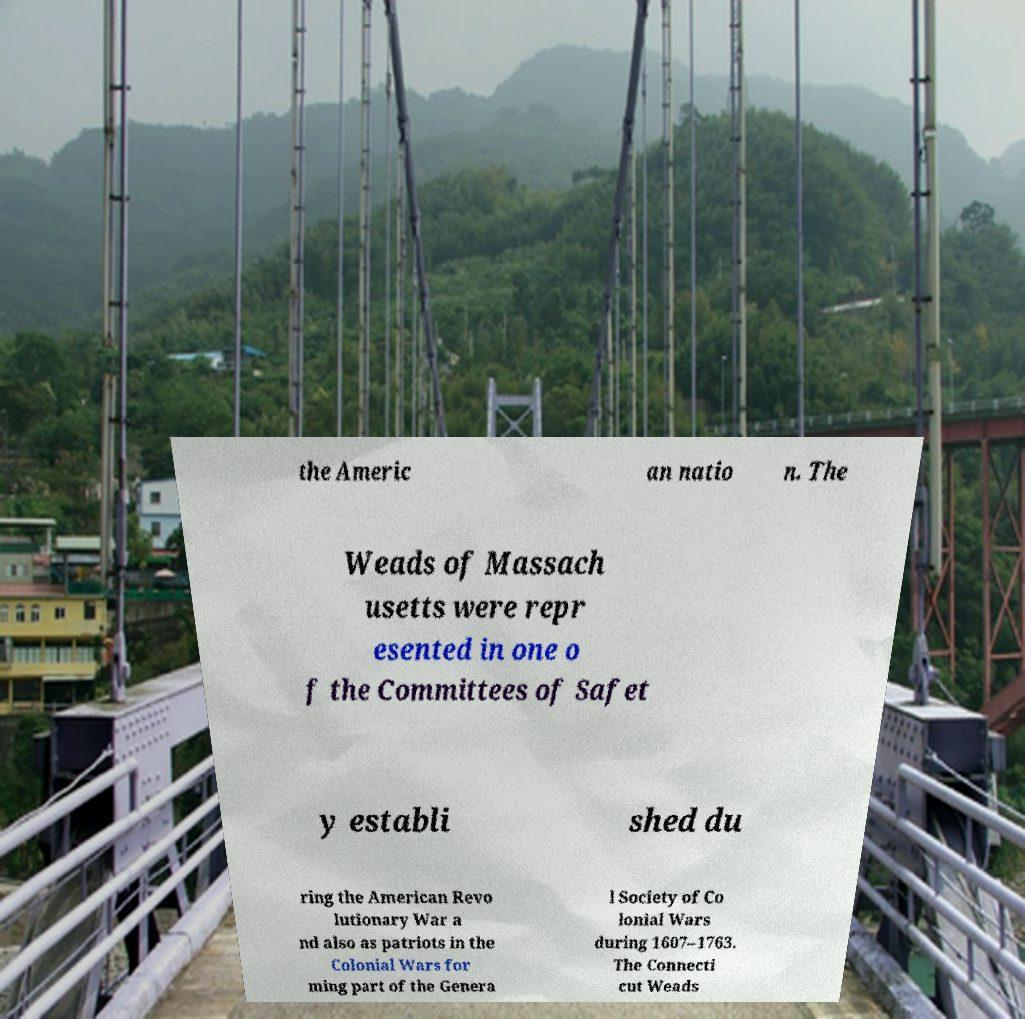Please identify and transcribe the text found in this image. the Americ an natio n. The Weads of Massach usetts were repr esented in one o f the Committees of Safet y establi shed du ring the American Revo lutionary War a nd also as patriots in the Colonial Wars for ming part of the Genera l Society of Co lonial Wars during 1607–1763. The Connecti cut Weads 